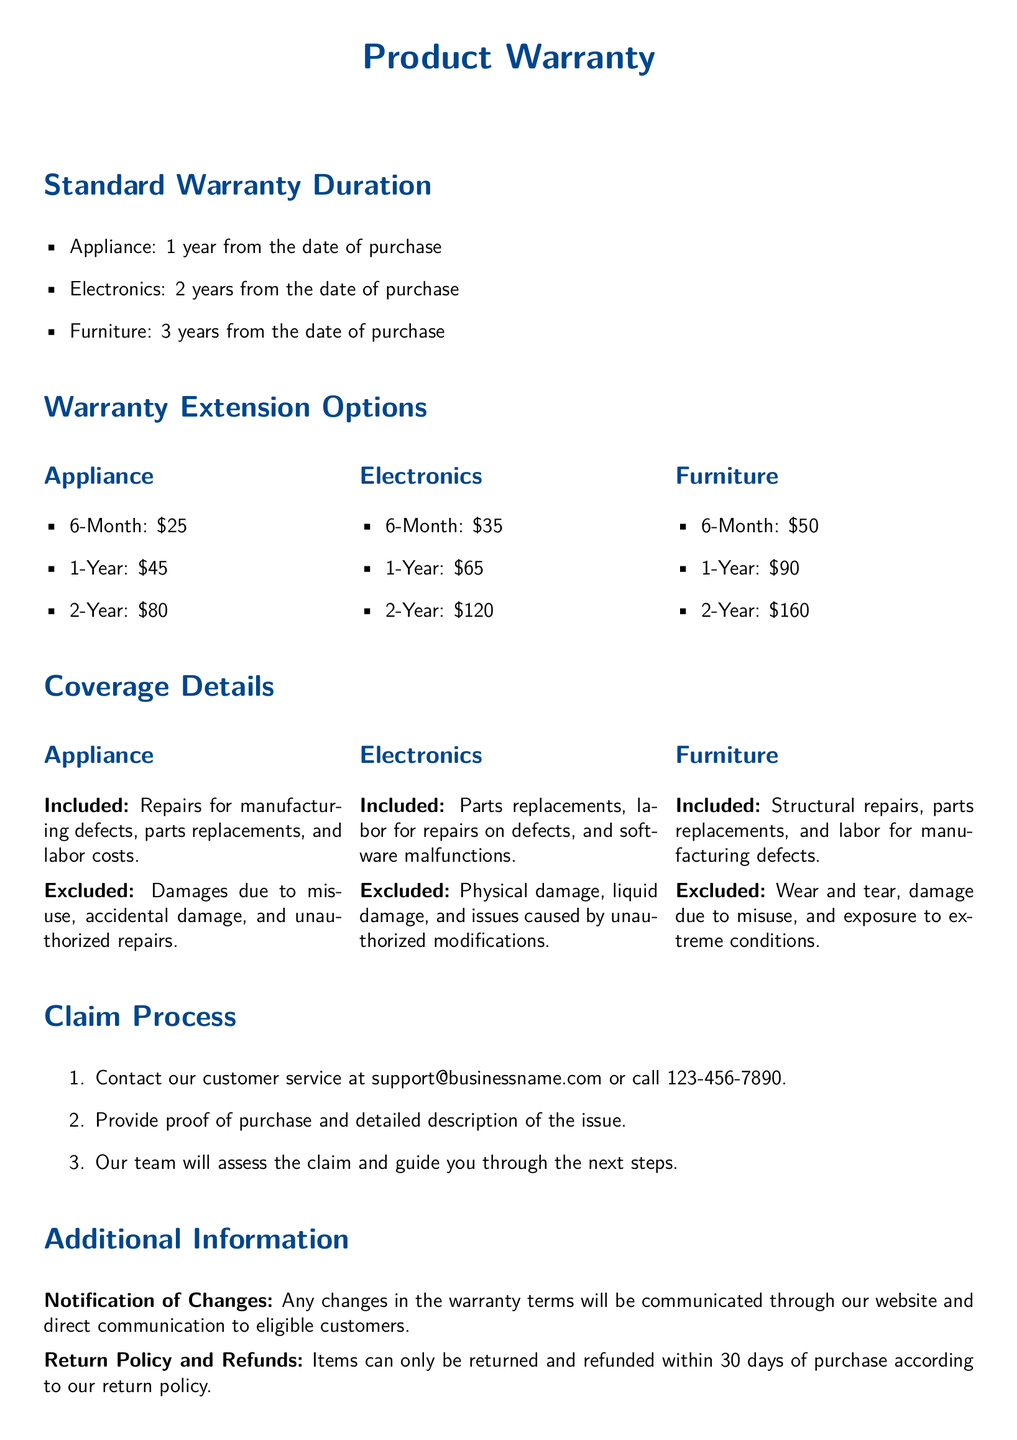What is the warranty duration for appliances? The warranty duration for appliances is specified in the document under the Standard Warranty Duration section.
Answer: 1 year How much does a 1-year warranty extension cost for electronics? The cost for a 1-year warranty extension for electronics is detailed in the Warranty Extension Options section.
Answer: $65 What types of damages are excluded under the appliance warranty? The document lists the exclusions under the Coverage Details section for appliances.
Answer: Damages due to misuse, accidental damage, and unauthorized repairs What is the claim process's first step? The first step in the claim process is outlined in the Claim Process section of the document.
Answer: Contact customer service How long is the return policy valid for? The return policy validity is specified in the Additional Information section of the document.
Answer: 30 days What is included in the furniture warranty? The inclusions for furniture warranty are stated in the Coverage Details section.
Answer: Structural repairs, parts replacements, and labor for manufacturing defects What is the cost of a 2-year warranty extension for appliances? The cost for a 2-year warranty extension for appliances can be found in the Warranty Extension Options section.
Answer: $80 What should a customer provide when making a claim? The necessary requirement for making a claim is mentioned in the Claim Process section.
Answer: Proof of purchase and detailed description of the issue How many years is the warranty for electronics? The duration of the warranty for electronics is specified in the Standard Warranty Duration section.
Answer: 2 years 